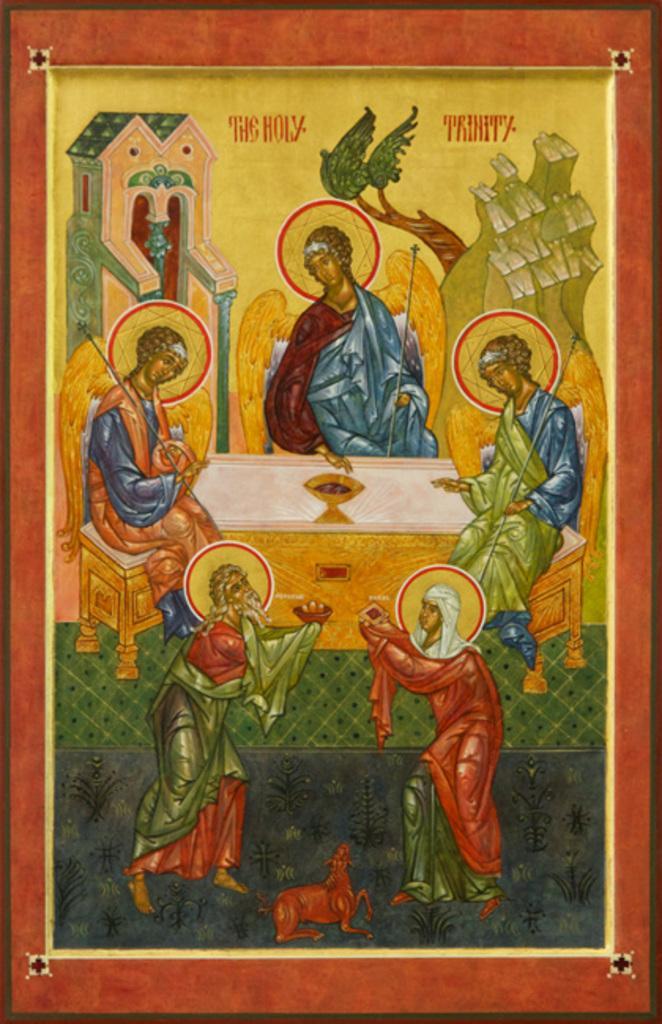Can you describe this image briefly? In this image we can see a painting. 